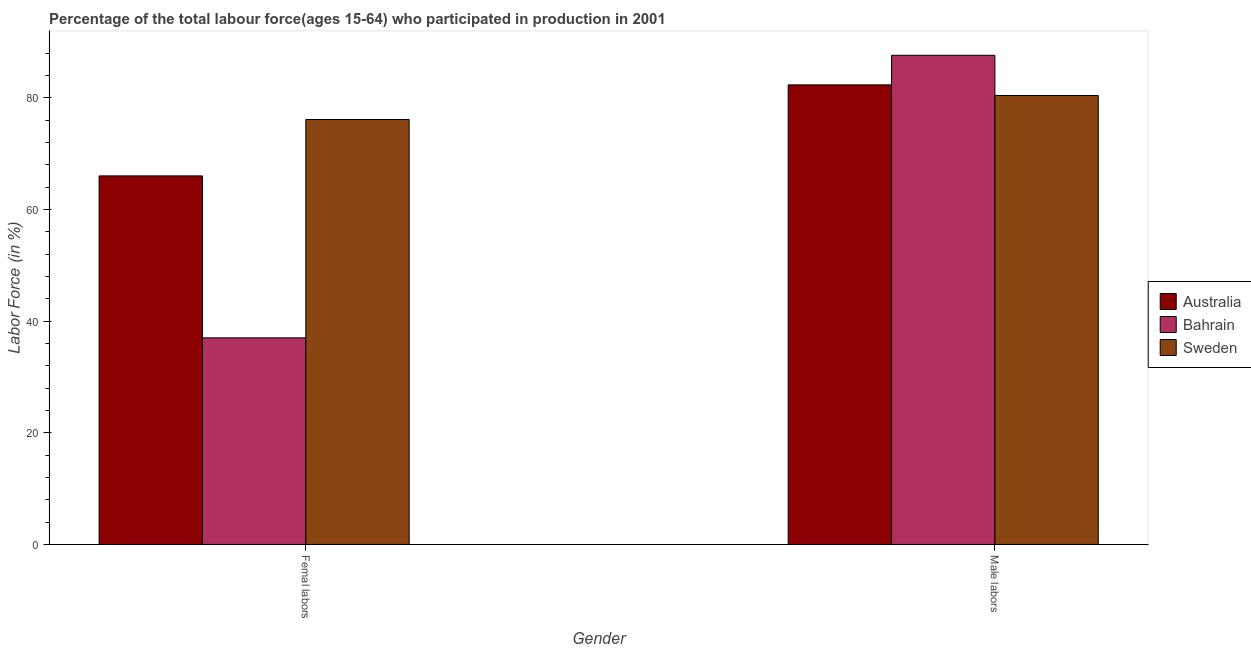How many different coloured bars are there?
Your answer should be very brief. 3. How many groups of bars are there?
Ensure brevity in your answer.  2. Are the number of bars per tick equal to the number of legend labels?
Provide a short and direct response. Yes. Are the number of bars on each tick of the X-axis equal?
Make the answer very short. Yes. What is the label of the 1st group of bars from the left?
Your answer should be compact. Femal labors. What is the percentage of male labour force in Bahrain?
Give a very brief answer. 87.6. Across all countries, what is the maximum percentage of male labour force?
Give a very brief answer. 87.6. Across all countries, what is the minimum percentage of female labor force?
Make the answer very short. 37. What is the total percentage of male labour force in the graph?
Your answer should be compact. 250.3. What is the difference between the percentage of male labour force in Bahrain and that in Sweden?
Provide a short and direct response. 7.2. What is the difference between the percentage of female labor force in Bahrain and the percentage of male labour force in Australia?
Keep it short and to the point. -45.3. What is the average percentage of female labor force per country?
Offer a very short reply. 59.7. What is the difference between the percentage of female labor force and percentage of male labour force in Australia?
Offer a very short reply. -16.3. What is the ratio of the percentage of male labour force in Sweden to that in Bahrain?
Your response must be concise. 0.92. Is the percentage of female labor force in Australia less than that in Bahrain?
Give a very brief answer. No. In how many countries, is the percentage of female labor force greater than the average percentage of female labor force taken over all countries?
Keep it short and to the point. 2. What does the 2nd bar from the left in Femal labors represents?
Make the answer very short. Bahrain. What does the 3rd bar from the right in Femal labors represents?
Keep it short and to the point. Australia. How many bars are there?
Your response must be concise. 6. Are all the bars in the graph horizontal?
Provide a short and direct response. No. What is the difference between two consecutive major ticks on the Y-axis?
Your answer should be very brief. 20. Are the values on the major ticks of Y-axis written in scientific E-notation?
Provide a succinct answer. No. Where does the legend appear in the graph?
Keep it short and to the point. Center right. How many legend labels are there?
Provide a short and direct response. 3. How are the legend labels stacked?
Give a very brief answer. Vertical. What is the title of the graph?
Give a very brief answer. Percentage of the total labour force(ages 15-64) who participated in production in 2001. What is the Labor Force (in %) in Australia in Femal labors?
Ensure brevity in your answer.  66. What is the Labor Force (in %) of Bahrain in Femal labors?
Offer a terse response. 37. What is the Labor Force (in %) in Sweden in Femal labors?
Give a very brief answer. 76.1. What is the Labor Force (in %) of Australia in Male labors?
Offer a very short reply. 82.3. What is the Labor Force (in %) of Bahrain in Male labors?
Ensure brevity in your answer.  87.6. What is the Labor Force (in %) in Sweden in Male labors?
Offer a terse response. 80.4. Across all Gender, what is the maximum Labor Force (in %) of Australia?
Provide a short and direct response. 82.3. Across all Gender, what is the maximum Labor Force (in %) of Bahrain?
Give a very brief answer. 87.6. Across all Gender, what is the maximum Labor Force (in %) of Sweden?
Provide a succinct answer. 80.4. Across all Gender, what is the minimum Labor Force (in %) of Bahrain?
Keep it short and to the point. 37. Across all Gender, what is the minimum Labor Force (in %) in Sweden?
Offer a terse response. 76.1. What is the total Labor Force (in %) of Australia in the graph?
Offer a terse response. 148.3. What is the total Labor Force (in %) of Bahrain in the graph?
Keep it short and to the point. 124.6. What is the total Labor Force (in %) of Sweden in the graph?
Your answer should be very brief. 156.5. What is the difference between the Labor Force (in %) in Australia in Femal labors and that in Male labors?
Your answer should be compact. -16.3. What is the difference between the Labor Force (in %) in Bahrain in Femal labors and that in Male labors?
Offer a terse response. -50.6. What is the difference between the Labor Force (in %) in Sweden in Femal labors and that in Male labors?
Offer a very short reply. -4.3. What is the difference between the Labor Force (in %) in Australia in Femal labors and the Labor Force (in %) in Bahrain in Male labors?
Offer a terse response. -21.6. What is the difference between the Labor Force (in %) of Australia in Femal labors and the Labor Force (in %) of Sweden in Male labors?
Give a very brief answer. -14.4. What is the difference between the Labor Force (in %) of Bahrain in Femal labors and the Labor Force (in %) of Sweden in Male labors?
Ensure brevity in your answer.  -43.4. What is the average Labor Force (in %) in Australia per Gender?
Keep it short and to the point. 74.15. What is the average Labor Force (in %) of Bahrain per Gender?
Your answer should be very brief. 62.3. What is the average Labor Force (in %) of Sweden per Gender?
Offer a terse response. 78.25. What is the difference between the Labor Force (in %) in Australia and Labor Force (in %) in Bahrain in Femal labors?
Provide a short and direct response. 29. What is the difference between the Labor Force (in %) of Australia and Labor Force (in %) of Sweden in Femal labors?
Provide a succinct answer. -10.1. What is the difference between the Labor Force (in %) of Bahrain and Labor Force (in %) of Sweden in Femal labors?
Keep it short and to the point. -39.1. What is the ratio of the Labor Force (in %) of Australia in Femal labors to that in Male labors?
Your answer should be compact. 0.8. What is the ratio of the Labor Force (in %) of Bahrain in Femal labors to that in Male labors?
Make the answer very short. 0.42. What is the ratio of the Labor Force (in %) of Sweden in Femal labors to that in Male labors?
Give a very brief answer. 0.95. What is the difference between the highest and the second highest Labor Force (in %) in Australia?
Give a very brief answer. 16.3. What is the difference between the highest and the second highest Labor Force (in %) in Bahrain?
Your response must be concise. 50.6. What is the difference between the highest and the lowest Labor Force (in %) of Australia?
Your answer should be compact. 16.3. What is the difference between the highest and the lowest Labor Force (in %) of Bahrain?
Keep it short and to the point. 50.6. What is the difference between the highest and the lowest Labor Force (in %) of Sweden?
Give a very brief answer. 4.3. 